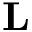Convert formula to latex. <formula><loc_0><loc_0><loc_500><loc_500>L</formula> 